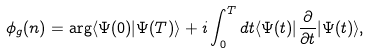<formula> <loc_0><loc_0><loc_500><loc_500>\phi _ { g } ( n ) = \arg \langle \Psi ( 0 ) | \Psi ( T ) \rangle + i \int _ { 0 } ^ { T } d t \langle \Psi ( t ) | \frac { \partial } { \partial t } | \Psi ( t ) \rangle ,</formula> 